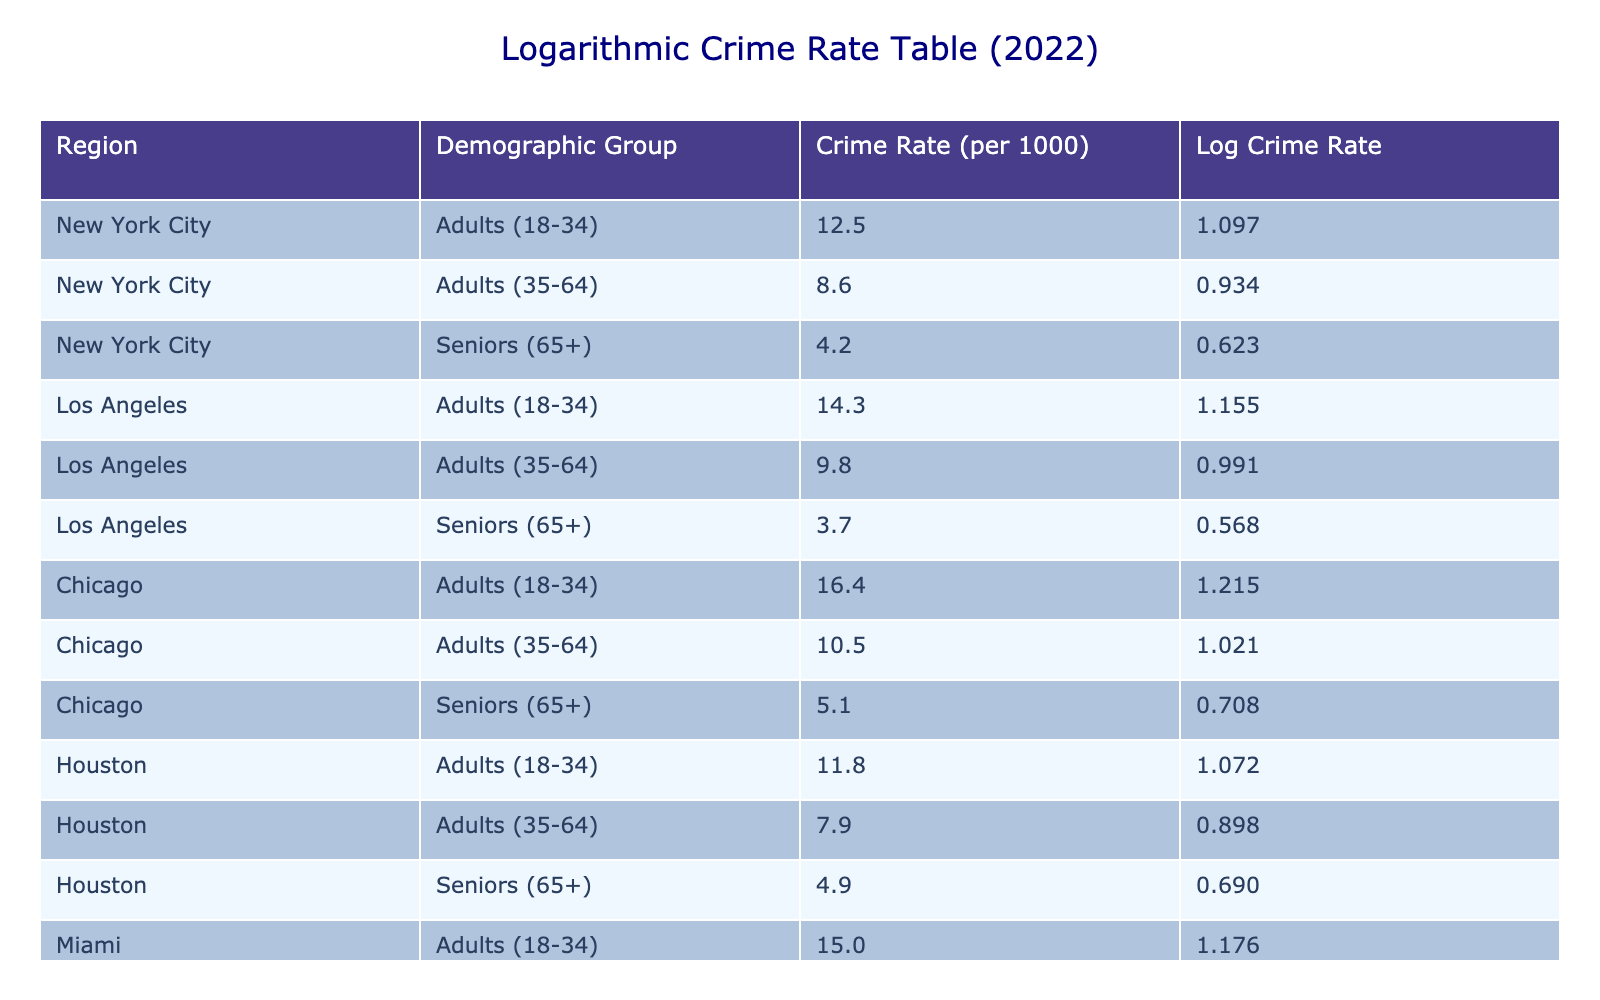What is the crime rate for seniors in New York City? Looking at the table, the demographic group "Seniors (65+)" in "New York City" has a crime rate of 4.2 per 1000 people listed in the table.
Answer: 4.2 Which region has the highest crime rate for adults aged 18-34? By comparing the crime rates for the demographic group "Adults (18-34)" across all regions listed in the table, Chicago shows the highest crime rate of 16.4 per 1000 people.
Answer: Chicago: 16.4 What is the difference in crime rates between adults aged 35-64 in Los Angeles and Miami? The crime rate for adults aged 35-64 in Los Angeles is 9.8 per 1000 people, while in Miami it is 9.2 per 1000 people. The difference is calculated by subtracting: 9.8 - 9.2 = 0.6.
Answer: 0.6 Is the crime rate for seniors lower in Houston compared to Chicago? Yes, the crime rate for seniors in Houston is 4.9 per 1000 people, while in Chicago it is 5.1 per 1000 people. Hence, Houston has a lower crime rate for seniors.
Answer: Yes What is the average crime rate for adults aged 35-64 across all regions? The crime rates for adults aged 35-64 in each region are: New York City: 8.6, Los Angeles: 9.8, Chicago: 10.5, Houston: 7.9, and Miami: 9.2. The sum is 8.6 + 9.8 + 10.5 + 7.9 + 9.2 = 55. The average is 55 divided by 5, which equals 11.
Answer: 11 What region shows the lowest crime rate for seniors? The table indicates that the region with the lowest crime rate for seniors is Los Angeles at 3.7 per 1000 people.
Answer: Los Angeles: 3.7 Are crime rates higher for adults aged 18-34 compared to seniors in Miami? Yes, the crime rate for adults aged 18-34 in Miami is 15.0 per 1000 people, which is higher than the crime rate for seniors at 6.3 per 1000 people.
Answer: Yes What is the logarithmic crime rate for adults aged 35-64 in New York City? In the table, the crime rate for adults aged 35-64 in New York City is 8.6. The logarithmic value is calculated as log10(8.6), which is approximately 0.935.
Answer: 0.935 